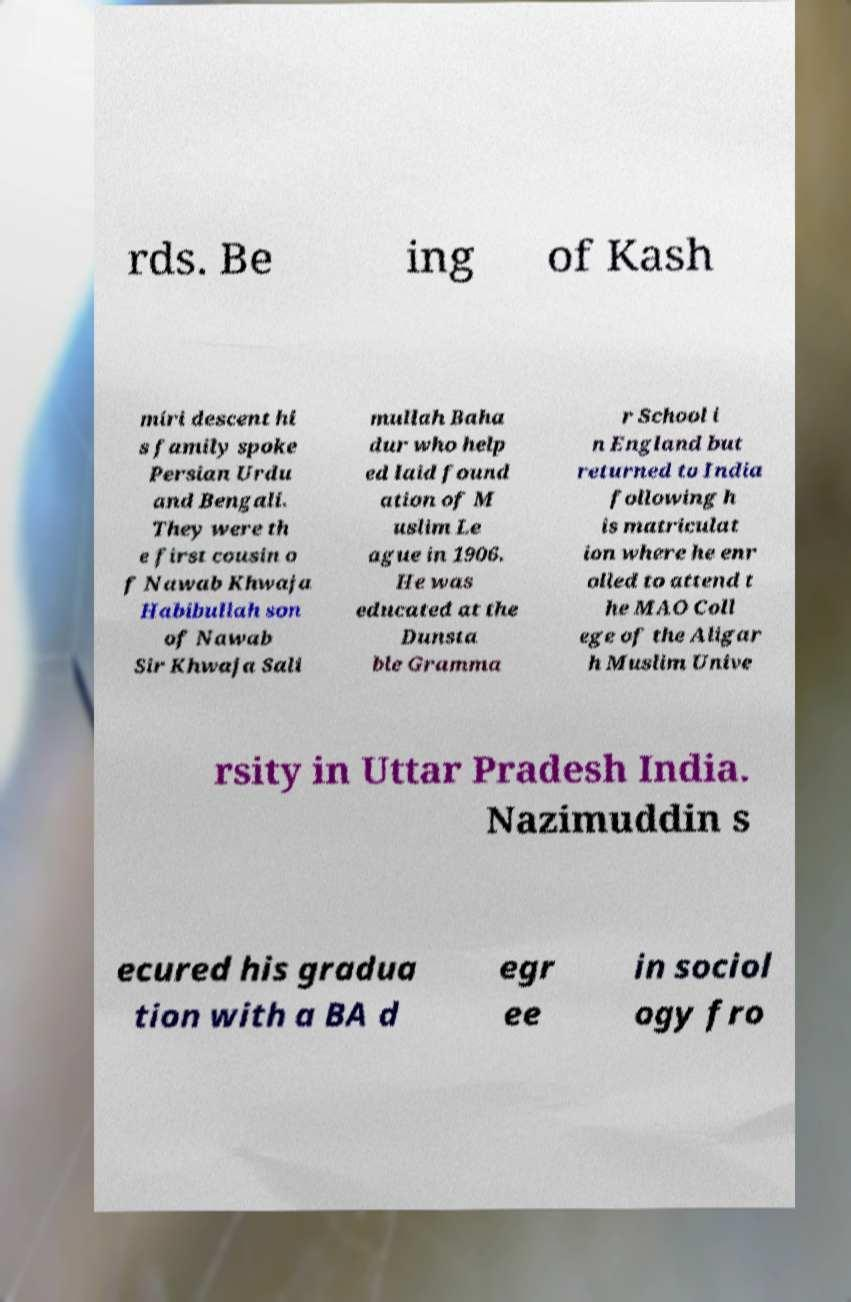What messages or text are displayed in this image? I need them in a readable, typed format. rds. Be ing of Kash miri descent hi s family spoke Persian Urdu and Bengali. They were th e first cousin o f Nawab Khwaja Habibullah son of Nawab Sir Khwaja Sali mullah Baha dur who help ed laid found ation of M uslim Le ague in 1906. He was educated at the Dunsta ble Gramma r School i n England but returned to India following h is matriculat ion where he enr olled to attend t he MAO Coll ege of the Aligar h Muslim Unive rsity in Uttar Pradesh India. Nazimuddin s ecured his gradua tion with a BA d egr ee in sociol ogy fro 